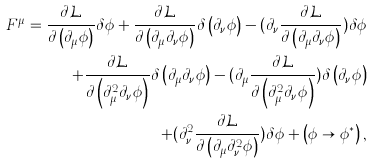<formula> <loc_0><loc_0><loc_500><loc_500>F ^ { \mu } = \frac { \partial \mathcal { L } } { \partial \left ( \partial _ { \mu } \phi \right ) } \delta \phi + \frac { \partial \mathcal { L } } { \partial \left ( \partial _ { \mu } \partial _ { \nu } \phi \right ) } \delta \left ( \partial _ { \nu } \phi \right ) - ( \partial _ { \nu } \frac { \partial \mathcal { L } } { \partial \left ( \partial _ { \mu } \partial _ { \nu } \phi \right ) } ) \delta \phi \\ + \frac { \partial \mathcal { L } } { \partial \left ( \partial _ { \mu } ^ { 2 } \partial _ { \nu } \phi \right ) } \delta \left ( \partial _ { \mu } \partial _ { \nu } \phi \right ) - ( \partial _ { \mu } \frac { \partial \mathcal { L } } { \partial \left ( \partial _ { \mu } ^ { 2 } \partial _ { \nu } \phi \right ) } ) \delta \left ( \partial _ { \nu } \phi \right ) \\ + ( \partial _ { \nu } ^ { 2 } \frac { \partial \mathcal { L } } { \partial \left ( \partial _ { \mu } \partial _ { \nu } ^ { 2 } \phi \right ) } ) \delta \phi + \left ( \phi \rightarrow \phi ^ { \ast } \right ) ,</formula> 